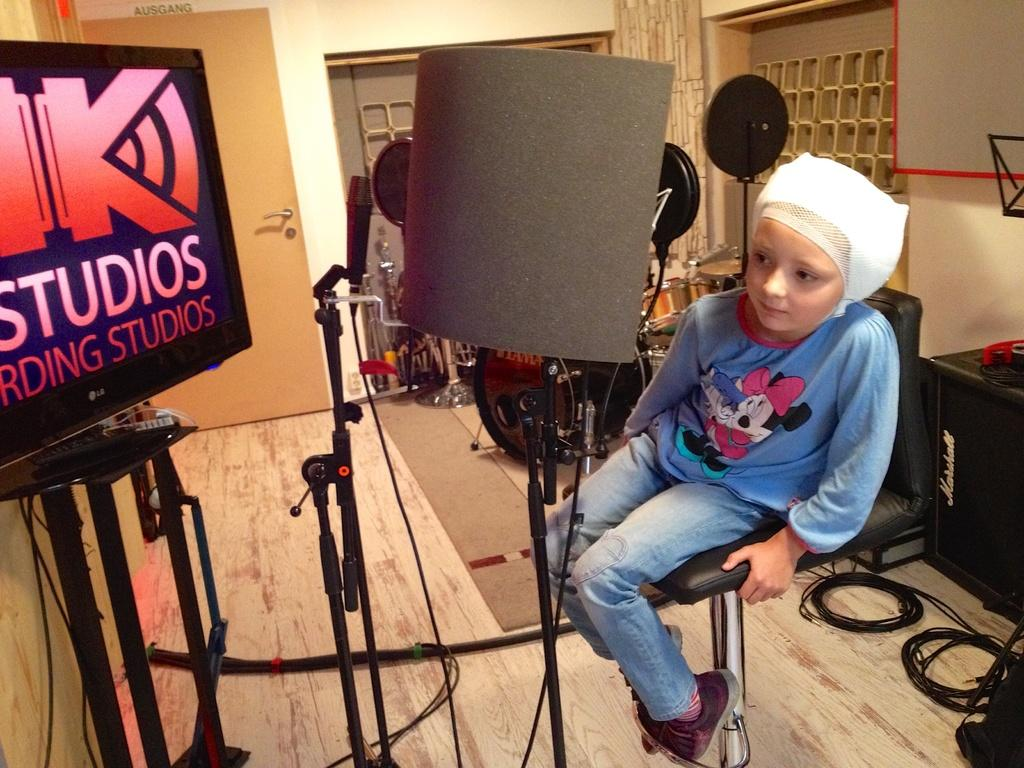Who or what is the main subject in the image? There is a child in the image. What is the child doing in the image? The child is sitting on a chair. What other objects related to sound can be seen in the image? Voice filters and a microphone are visible in the image. What color is the balloon that the child is holding in the image? There is no balloon present in the image. How does the child defend against the attack in the image? There is no attack present in the image. 